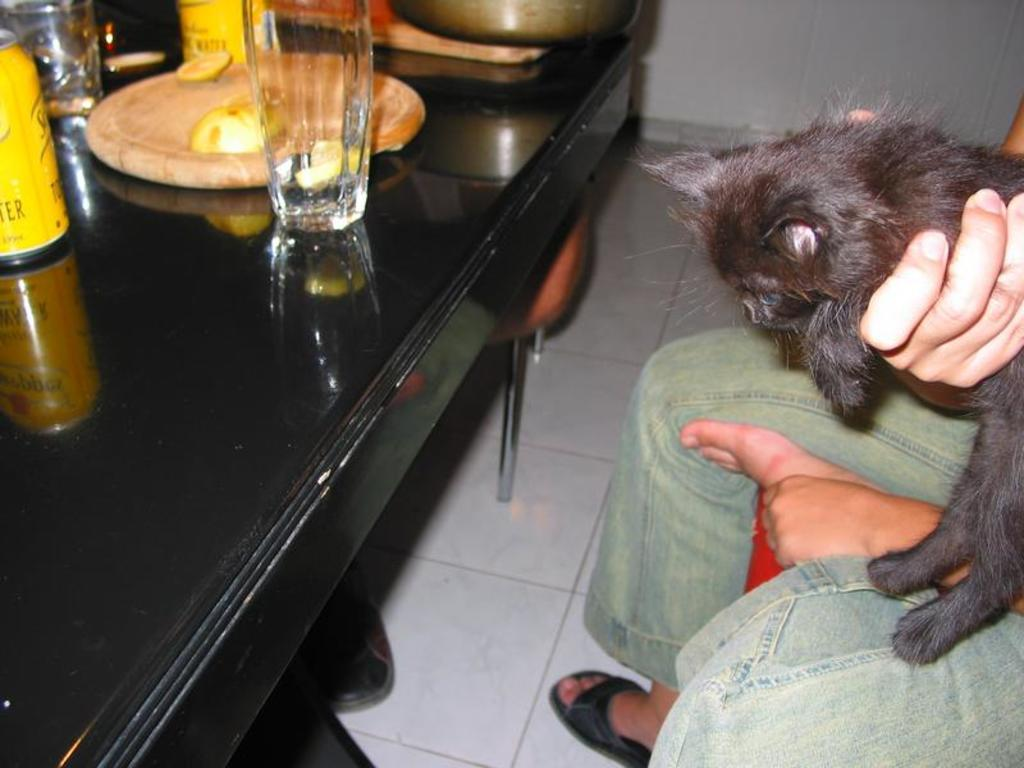Who or what is the main subject in the image? There is a person in the image. What is the person holding in the image? The person is holding a cat. What object is visible in front of the person? There is a table in front of the person. How many sheep are visible in the image? There are no sheep present in the image. What type of rod is being used by the person in the image? There is no rod visible in the image; the person is holding a cat. 